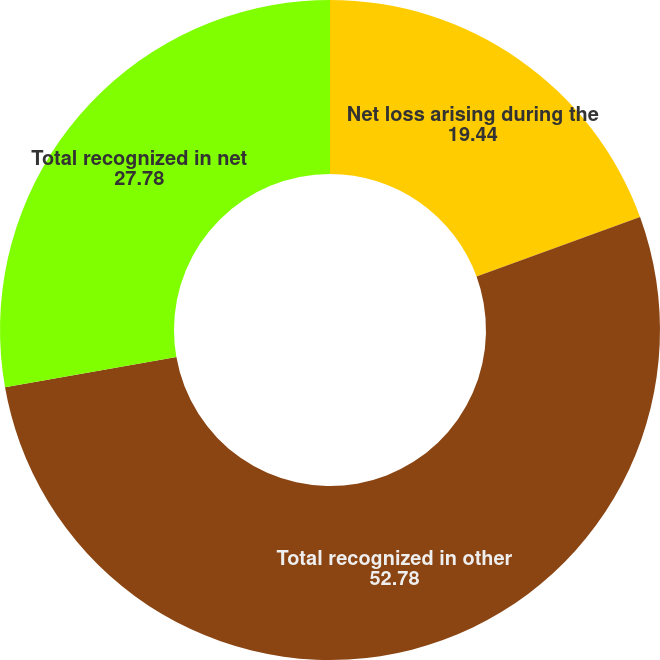Convert chart to OTSL. <chart><loc_0><loc_0><loc_500><loc_500><pie_chart><fcel>Net loss arising during the<fcel>Total recognized in other<fcel>Total recognized in net<nl><fcel>19.44%<fcel>52.78%<fcel>27.78%<nl></chart> 